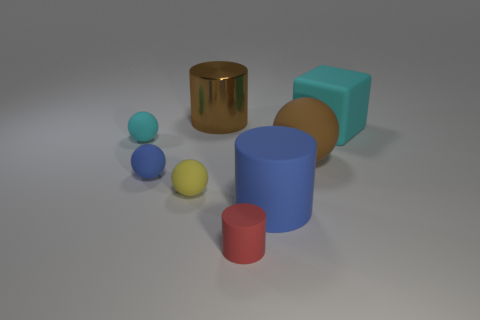Subtract all big blue matte cylinders. How many cylinders are left? 2 Subtract all cyan balls. How many balls are left? 3 Subtract 1 cylinders. How many cylinders are left? 2 Add 2 tiny cyan matte cylinders. How many objects exist? 10 Subtract all cylinders. How many objects are left? 5 Subtract all red balls. How many red cylinders are left? 1 Add 5 rubber cylinders. How many rubber cylinders are left? 7 Add 3 red matte things. How many red matte things exist? 4 Subtract 0 green cylinders. How many objects are left? 8 Subtract all cyan cylinders. Subtract all cyan cubes. How many cylinders are left? 3 